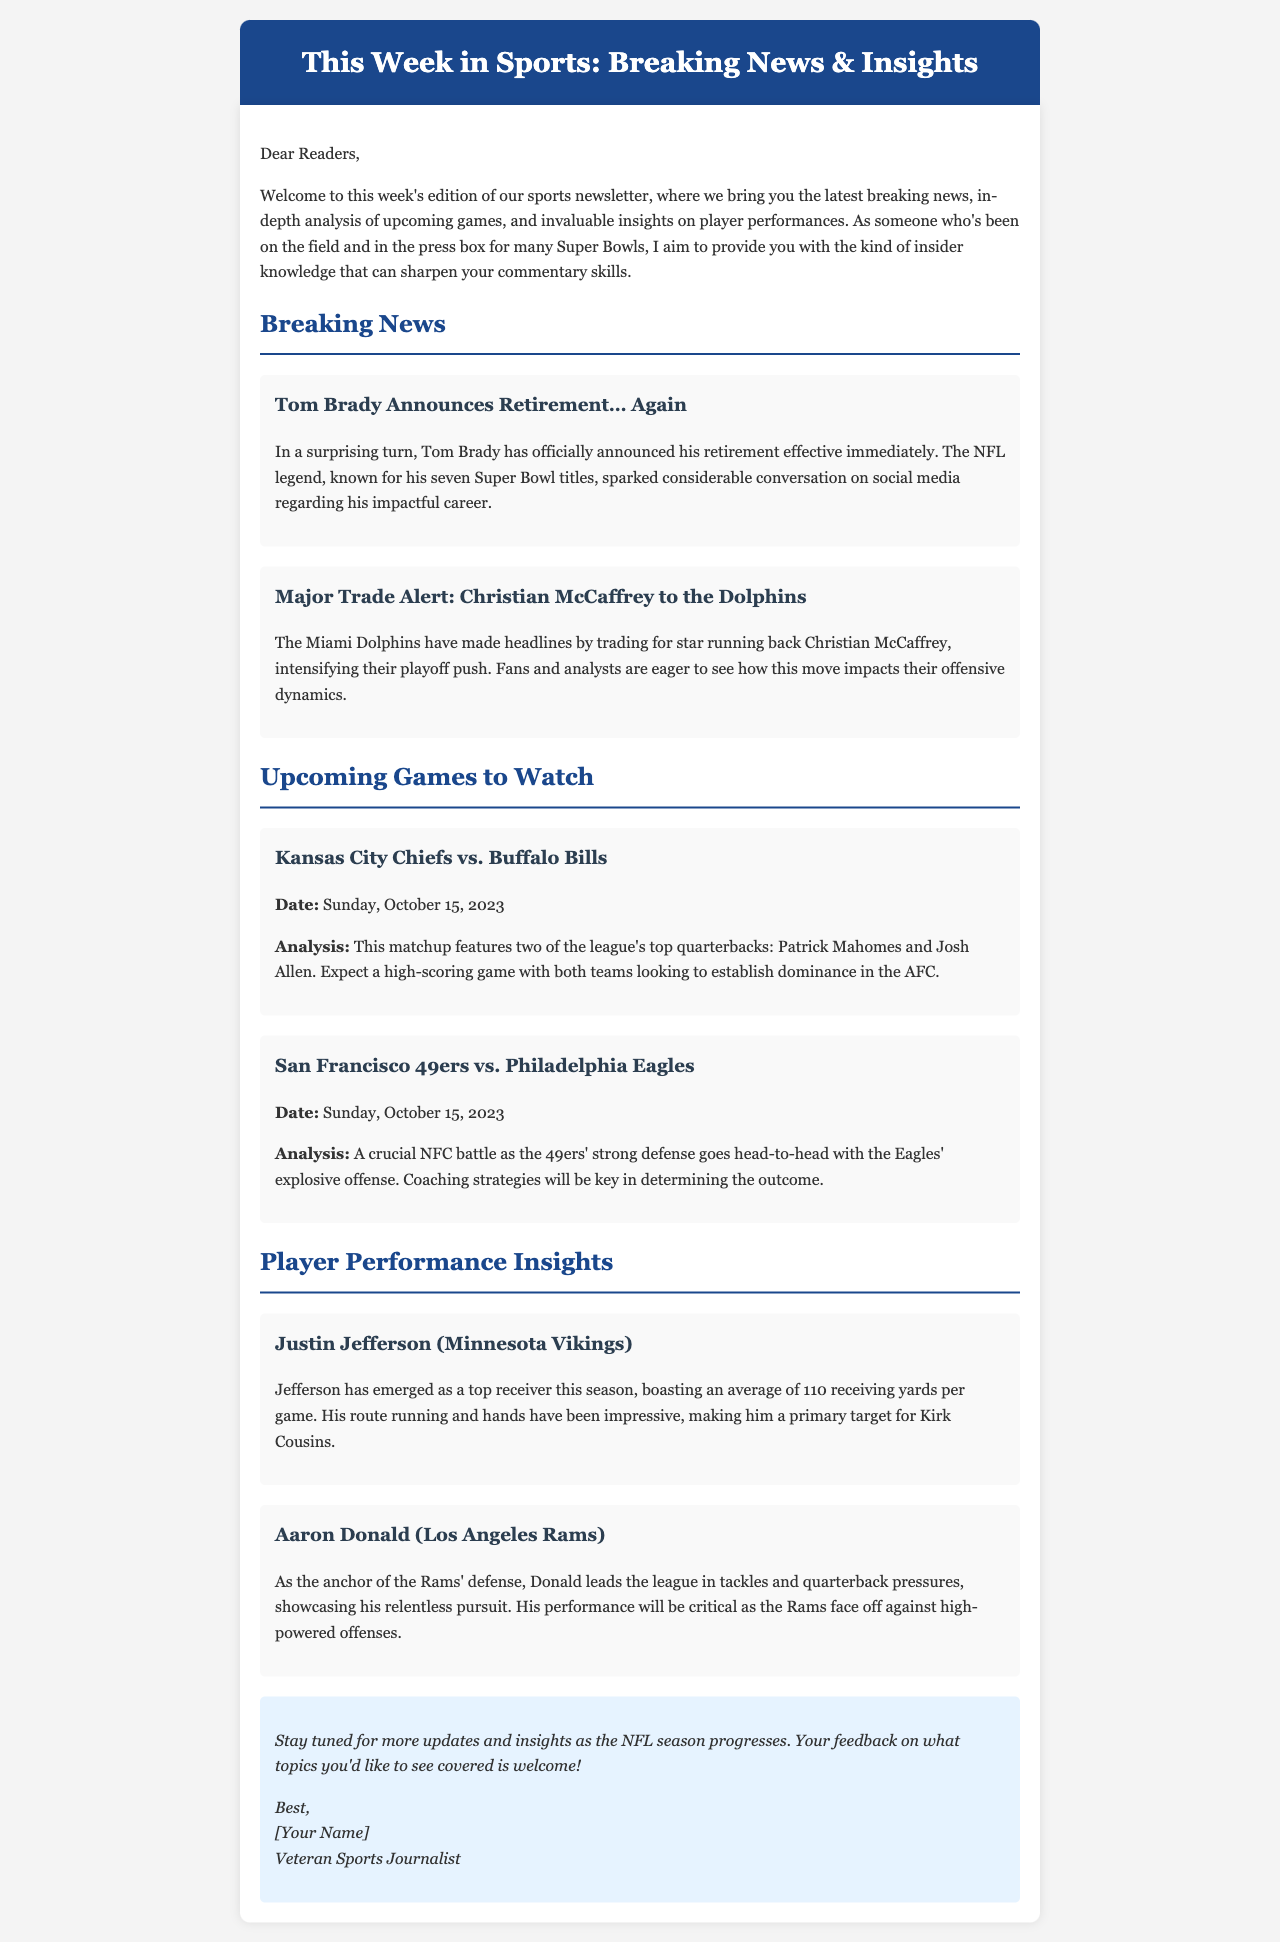What date is the Kansas City Chiefs vs. Buffalo Bills game? The date of the game is highlighted in the upcoming games section.
Answer: Sunday, October 15, 2023 Who announced retirement effective immediately? The breaking news section mentions the name of the player who announced retirement.
Answer: Tom Brady Which team did Christian McCaffrey get traded to? The major trade alert specifically states the new team of Christian McCaffrey.
Answer: Dolphins What is Justin Jefferson's average receiving yards per game? The player performance insights provide statistical information about his performance.
Answer: 110 receiving yards What will be crucial in determining the outcome of the 49ers vs. Eagles game? The analysis highlights what factors are important in this NFC battle.
Answer: Coaching strategies Who leads the league in tackles and quarterback pressures? This detail is specified in the player performance insights section about Aaron Donald.
Answer: Aaron Donald What two teams are highlighted in the upcoming games? This information is found in the section detailing the games to watch.
Answer: Chiefs and Bills; 49ers and Eagles What is the main theme of the newsletter? The introductory paragraph defines the key focus and aim of the newsletter.
Answer: Breaking news and insights 